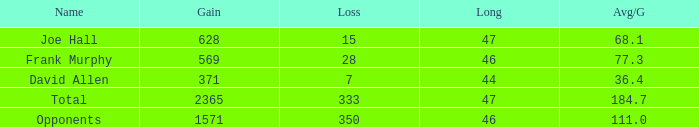How much Avg/G has a Gain smaller than 1571, and a Long smaller than 46? 1.0. 